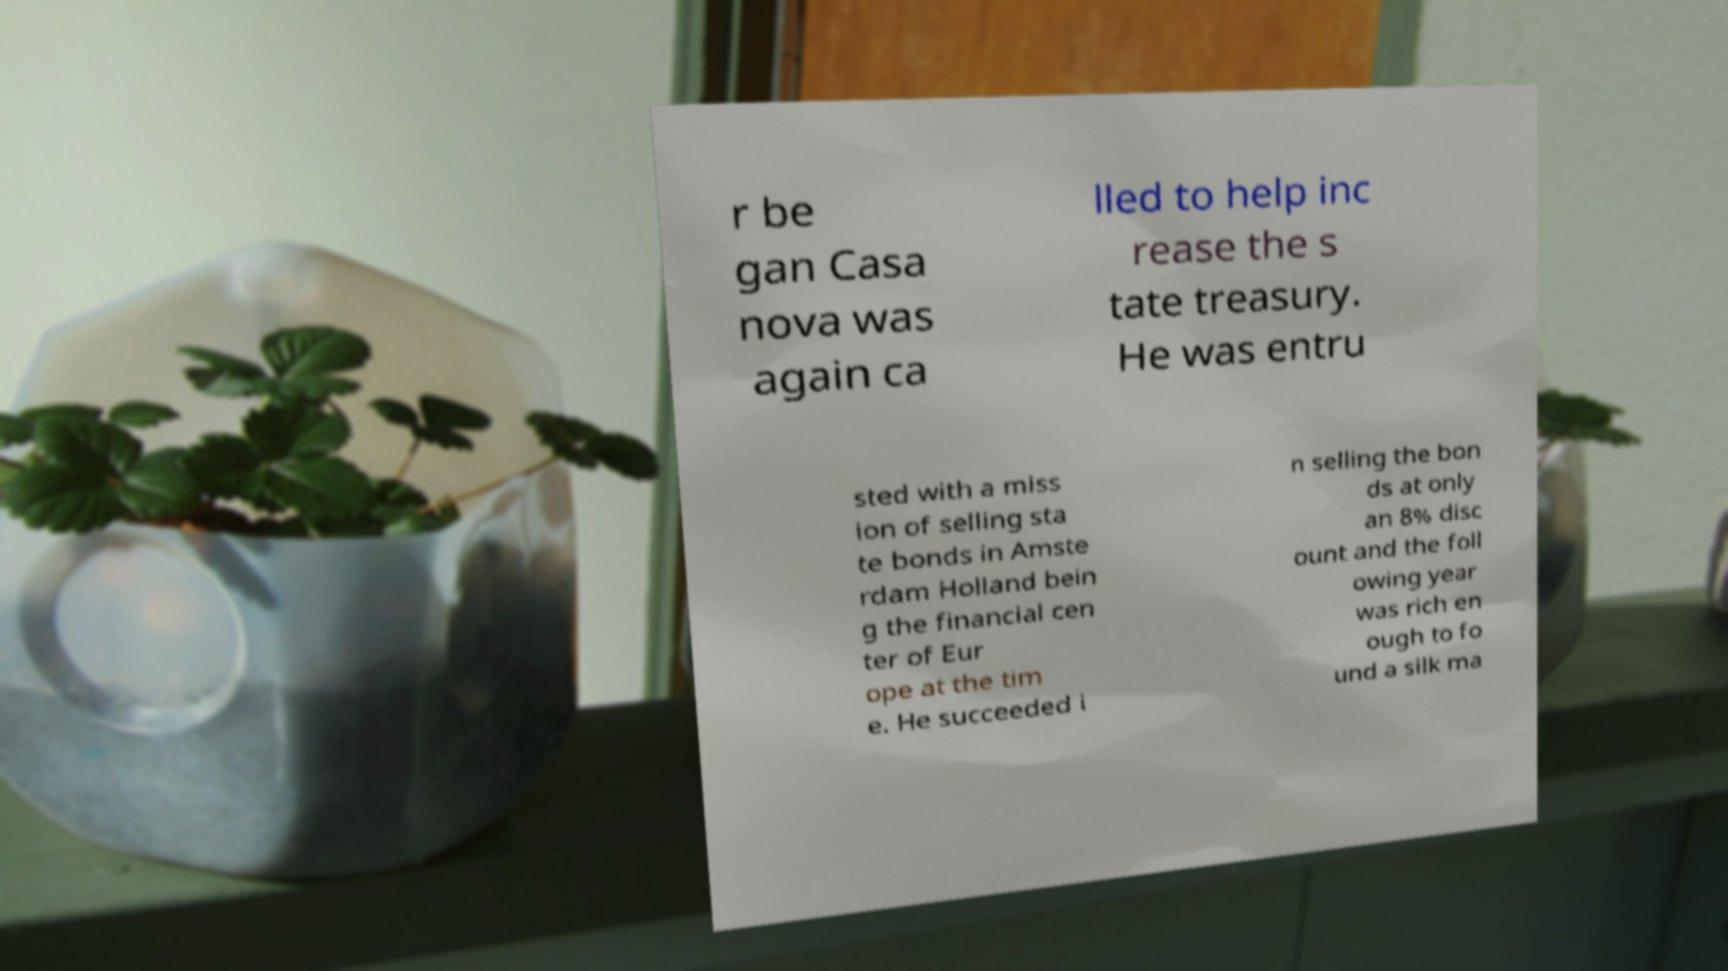Please identify and transcribe the text found in this image. r be gan Casa nova was again ca lled to help inc rease the s tate treasury. He was entru sted with a miss ion of selling sta te bonds in Amste rdam Holland bein g the financial cen ter of Eur ope at the tim e. He succeeded i n selling the bon ds at only an 8% disc ount and the foll owing year was rich en ough to fo und a silk ma 